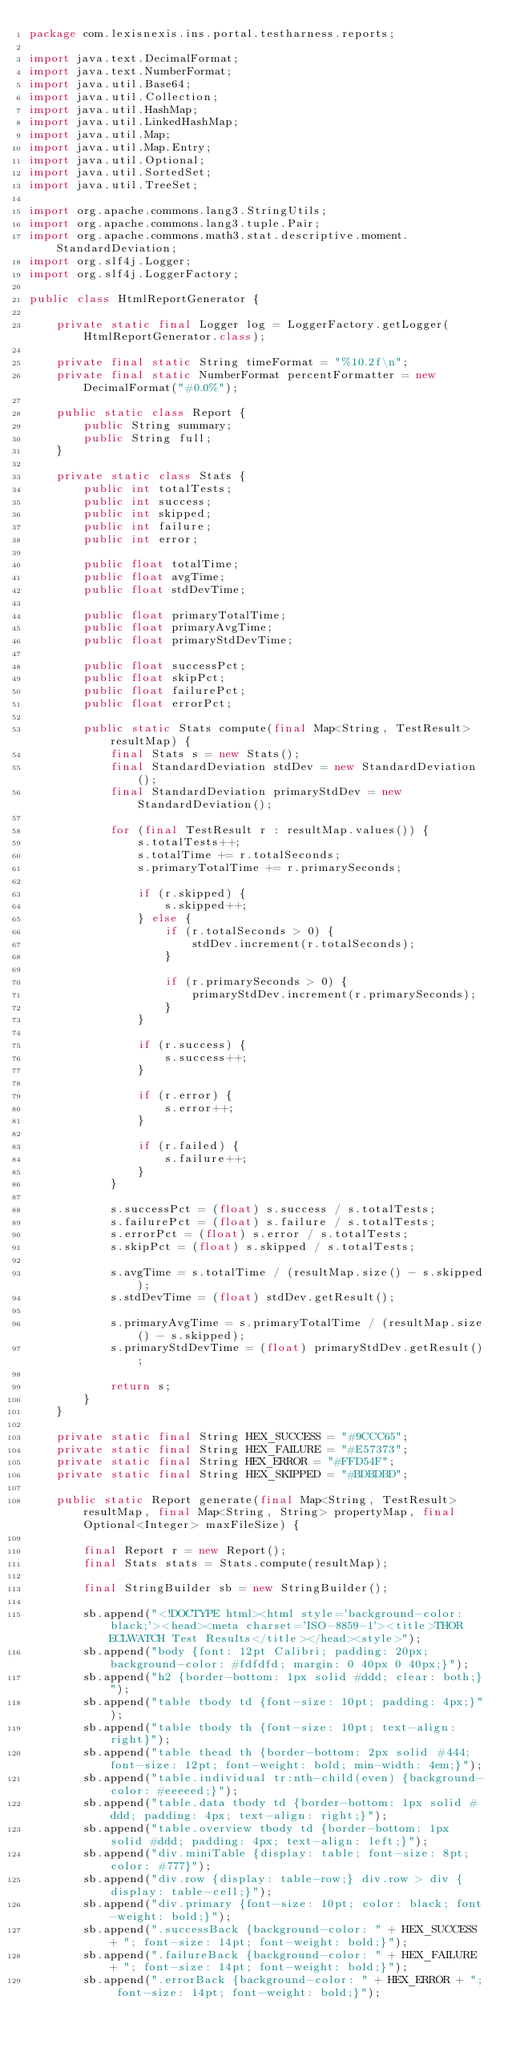<code> <loc_0><loc_0><loc_500><loc_500><_Java_>package com.lexisnexis.ins.portal.testharness.reports;

import java.text.DecimalFormat;
import java.text.NumberFormat;
import java.util.Base64;
import java.util.Collection;
import java.util.HashMap;
import java.util.LinkedHashMap;
import java.util.Map;
import java.util.Map.Entry;
import java.util.Optional;
import java.util.SortedSet;
import java.util.TreeSet;

import org.apache.commons.lang3.StringUtils;
import org.apache.commons.lang3.tuple.Pair;
import org.apache.commons.math3.stat.descriptive.moment.StandardDeviation;
import org.slf4j.Logger;
import org.slf4j.LoggerFactory;

public class HtmlReportGenerator {

	private static final Logger log = LoggerFactory.getLogger(HtmlReportGenerator.class);

	private final static String timeFormat = "%10.2f\n";
	private final static NumberFormat percentFormatter = new DecimalFormat("#0.0%");

	public static class Report {
		public String summary;
		public String full;
	}

	private static class Stats {
		public int totalTests;
		public int success;
		public int skipped;
		public int failure;
		public int error;

		public float totalTime;
		public float avgTime;
		public float stdDevTime;

		public float primaryTotalTime;
		public float primaryAvgTime;
		public float primaryStdDevTime;

		public float successPct;
		public float skipPct;
		public float failurePct;
		public float errorPct;

		public static Stats compute(final Map<String, TestResult> resultMap) {
			final Stats s = new Stats();
			final StandardDeviation stdDev = new StandardDeviation();
			final StandardDeviation primaryStdDev = new StandardDeviation();

			for (final TestResult r : resultMap.values()) {
				s.totalTests++;
				s.totalTime += r.totalSeconds;
				s.primaryTotalTime += r.primarySeconds;

				if (r.skipped) {
					s.skipped++;
				} else {
					if (r.totalSeconds > 0) {
						stdDev.increment(r.totalSeconds);
					}

					if (r.primarySeconds > 0) {
						primaryStdDev.increment(r.primarySeconds);
					}
				}

				if (r.success) {
					s.success++;
				}

				if (r.error) {
					s.error++;
				}

				if (r.failed) {
					s.failure++;
				}
			}

			s.successPct = (float) s.success / s.totalTests;
			s.failurePct = (float) s.failure / s.totalTests;
			s.errorPct = (float) s.error / s.totalTests;
			s.skipPct = (float) s.skipped / s.totalTests;

			s.avgTime = s.totalTime / (resultMap.size() - s.skipped);
			s.stdDevTime = (float) stdDev.getResult();

			s.primaryAvgTime = s.primaryTotalTime / (resultMap.size() - s.skipped);
			s.primaryStdDevTime = (float) primaryStdDev.getResult();

			return s;
		}
	}

	private static final String HEX_SUCCESS = "#9CCC65";
	private static final String HEX_FAILURE = "#E57373";
	private static final String HEX_ERROR = "#FFD54F";
	private static final String HEX_SKIPPED = "#BDBDBD";

	public static Report generate(final Map<String, TestResult> resultMap, final Map<String, String> propertyMap, final Optional<Integer> maxFileSize) {

		final Report r = new Report();
		final Stats stats = Stats.compute(resultMap);

		final StringBuilder sb = new StringBuilder();

		sb.append("<!DOCTYPE html><html style='background-color: black;'><head><meta charset='ISO-8859-1'><title>THOR ECLWATCH Test Results</title></head><style>");
		sb.append("body {font: 12pt Calibri; padding: 20px; background-color: #fdfdfd; margin: 0 40px 0 40px;}");
		sb.append("h2 {border-bottom: 1px solid #ddd; clear: both;}");
		sb.append("table tbody td {font-size: 10pt; padding: 4px;}");
		sb.append("table tbody th {font-size: 10pt; text-align: right}");
		sb.append("table thead th {border-bottom: 2px solid #444; font-size: 12pt; font-weight: bold; min-width: 4em;}");
		sb.append("table.individual tr:nth-child(even) {background-color: #eeeeed;}");
		sb.append("table.data tbody td {border-bottom: 1px solid #ddd; padding: 4px; text-align: right;}");
		sb.append("table.overview tbody td {border-bottom: 1px solid #ddd; padding: 4px; text-align: left;}");
		sb.append("div.miniTable {display: table; font-size: 8pt; color: #777}");
		sb.append("div.row {display: table-row;} div.row > div {display: table-cell;}");
		sb.append("div.primary {font-size: 10pt; color: black; font-weight: bold;}");
		sb.append(".successBack {background-color: " + HEX_SUCCESS + "; font-size: 14pt; font-weight: bold;}");
		sb.append(".failureBack {background-color: " + HEX_FAILURE + "; font-size: 14pt; font-weight: bold;}");
		sb.append(".errorBack {background-color: " + HEX_ERROR + "; font-size: 14pt; font-weight: bold;}");</code> 